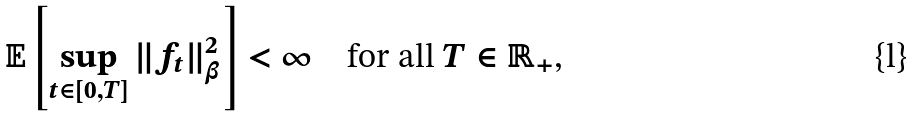Convert formula to latex. <formula><loc_0><loc_0><loc_500><loc_500>\mathbb { E } \left [ \sup _ { t \in [ 0 , T ] } \| f _ { t } \| _ { \beta } ^ { 2 } \right ] < \infty \quad \text {for all $T \in \mathbb{R}_{+}$,}</formula> 